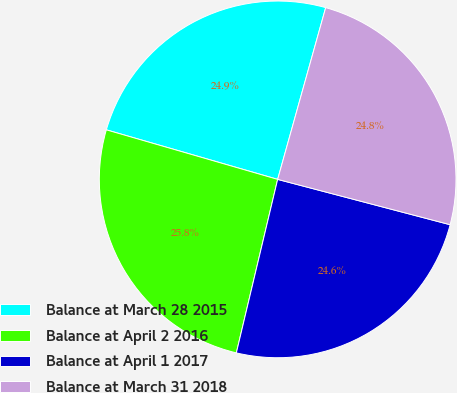Convert chart. <chart><loc_0><loc_0><loc_500><loc_500><pie_chart><fcel>Balance at March 28 2015<fcel>Balance at April 2 2016<fcel>Balance at April 1 2017<fcel>Balance at March 31 2018<nl><fcel>24.86%<fcel>25.76%<fcel>24.63%<fcel>24.75%<nl></chart> 